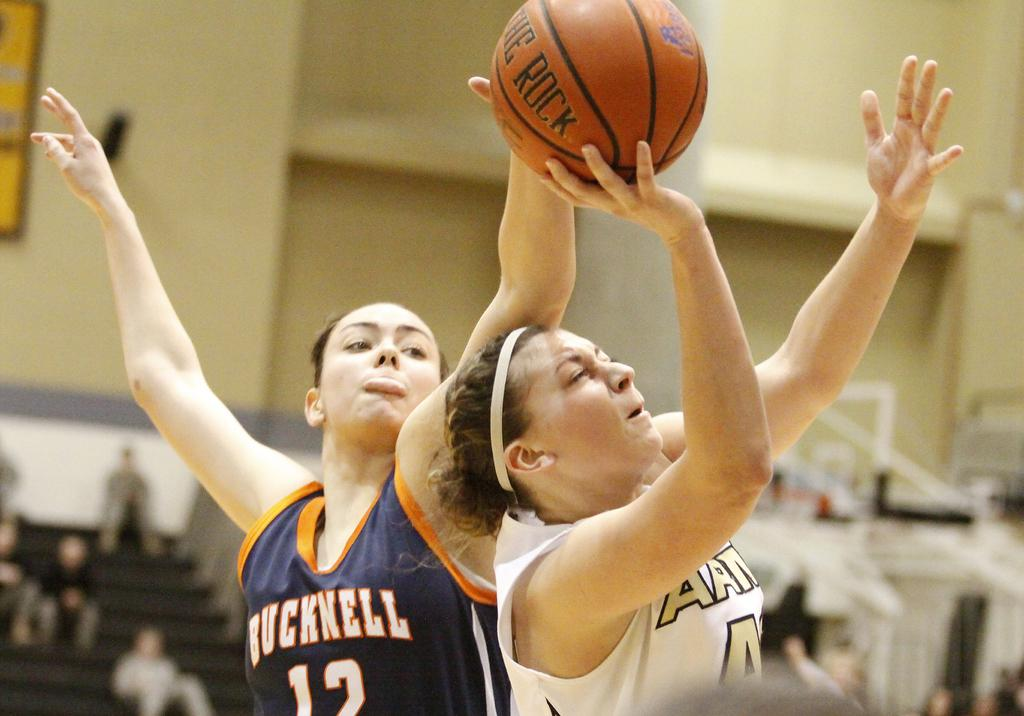How many people are in the image? There are two men in the image. What activity are the two men engaged in? The two men are playing basketball. Can you describe the background of the image? The background of the image is blurred. What type of lift is present in the image? There is no lift present in the image; it features two men playing basketball. Can you see any bombs in the image? There are no bombs present in the image. 